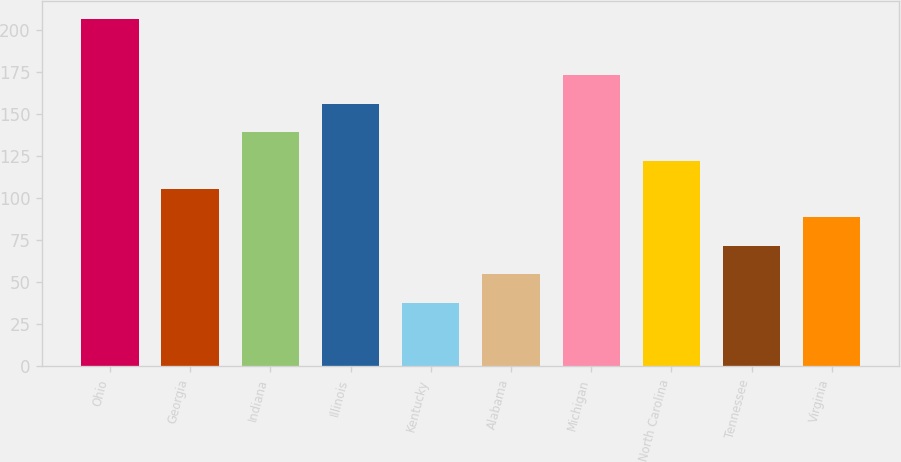Convert chart. <chart><loc_0><loc_0><loc_500><loc_500><bar_chart><fcel>Ohio<fcel>Georgia<fcel>Indiana<fcel>Illinois<fcel>Kentucky<fcel>Alabama<fcel>Michigan<fcel>North Carolina<fcel>Tennessee<fcel>Virginia<nl><fcel>207<fcel>105.6<fcel>139.4<fcel>156.3<fcel>38<fcel>54.9<fcel>173.2<fcel>122.5<fcel>71.8<fcel>88.7<nl></chart> 